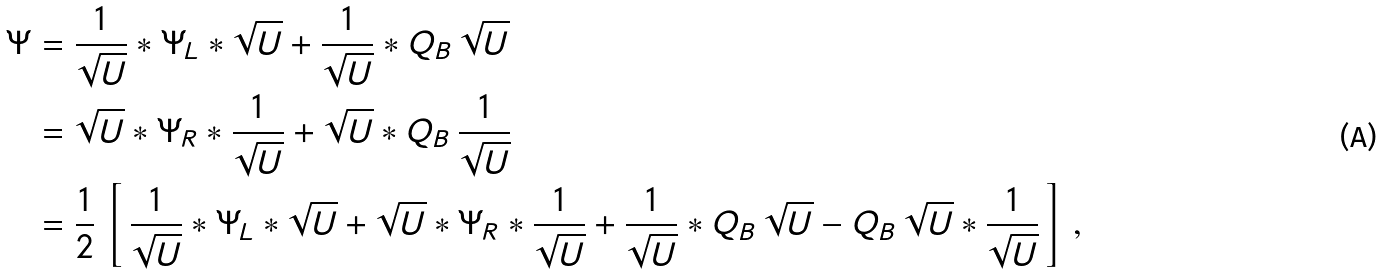<formula> <loc_0><loc_0><loc_500><loc_500>\Psi & = \frac { 1 } { \sqrt { U } } \ast \Psi _ { L } \ast \sqrt { U } + \frac { 1 } { \sqrt { U } } \ast Q _ { B } \, \sqrt { U } \\ & = \sqrt { U } \ast \Psi _ { R } \ast \frac { 1 } { \sqrt { U } } + \sqrt { U } \ast Q _ { B } \, \frac { 1 } { \sqrt { U } } \\ & = \frac { 1 } { 2 } \, \left [ \, \frac { 1 } { \sqrt { U } } \ast \Psi _ { L } \ast \sqrt { U } + \sqrt { U } \ast \Psi _ { R } \ast \frac { 1 } { \sqrt { U } } + \frac { 1 } { \sqrt { U } } \ast Q _ { B } \, \sqrt { U } - Q _ { B } \, \sqrt { U } \ast \frac { 1 } { \sqrt { U } } \, \right ] \, ,</formula> 